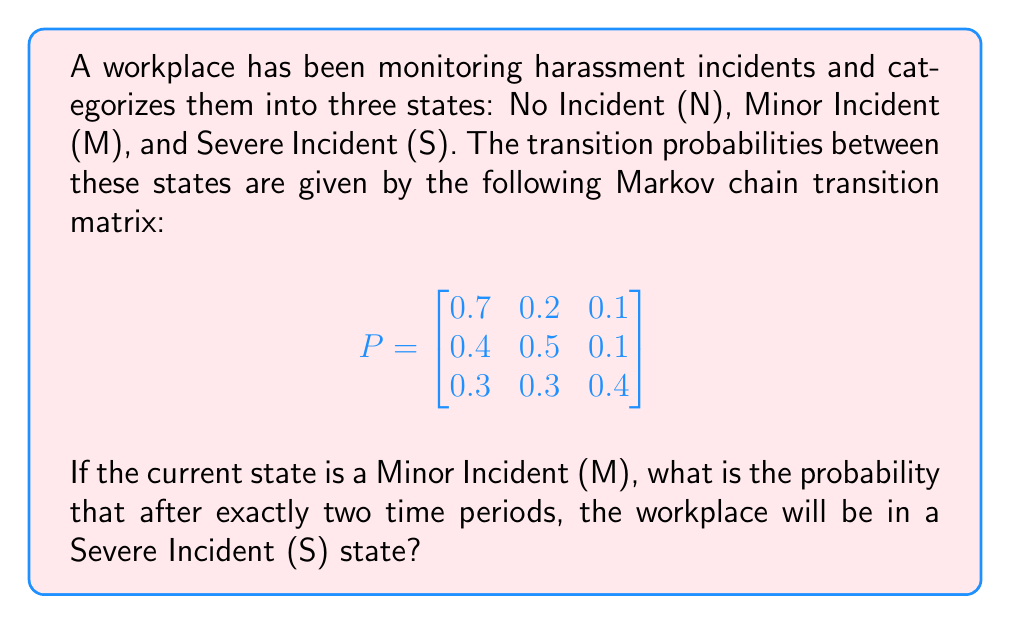Show me your answer to this math problem. To solve this problem, we need to use the Chapman-Kolmogorov equations for Markov chains. The probability of moving from state i to state j in n steps is given by the (i,j) entry of the matrix $P^n$.

In this case, we want to find the probability of moving from state M to state S in 2 steps. This corresponds to the (2,3) entry of $P^2$ (since M is the second state and S is the third state in our ordering).

Let's calculate $P^2$:

$$P^2 = P \times P = \begin{bmatrix}
0.7 & 0.2 & 0.1 \\
0.4 & 0.5 & 0.1 \\
0.3 & 0.3 & 0.4
\end{bmatrix} \times \begin{bmatrix}
0.7 & 0.2 & 0.1 \\
0.4 & 0.5 & 0.1 \\
0.3 & 0.3 & 0.4
\end{bmatrix}$$

Multiplying these matrices:

$$P^2 = \begin{bmatrix}
0.58 & 0.27 & 0.15 \\
0.53 & 0.32 & 0.15 \\
0.43 & 0.33 & 0.24
\end{bmatrix}$$

The probability we're looking for is the (2,3) entry of this matrix, which is 0.15 or 15%.

This means that if the current state is a Minor Incident, there is a 15% chance that after two time periods, the workplace will be in a Severe Incident state.
Answer: 0.15 